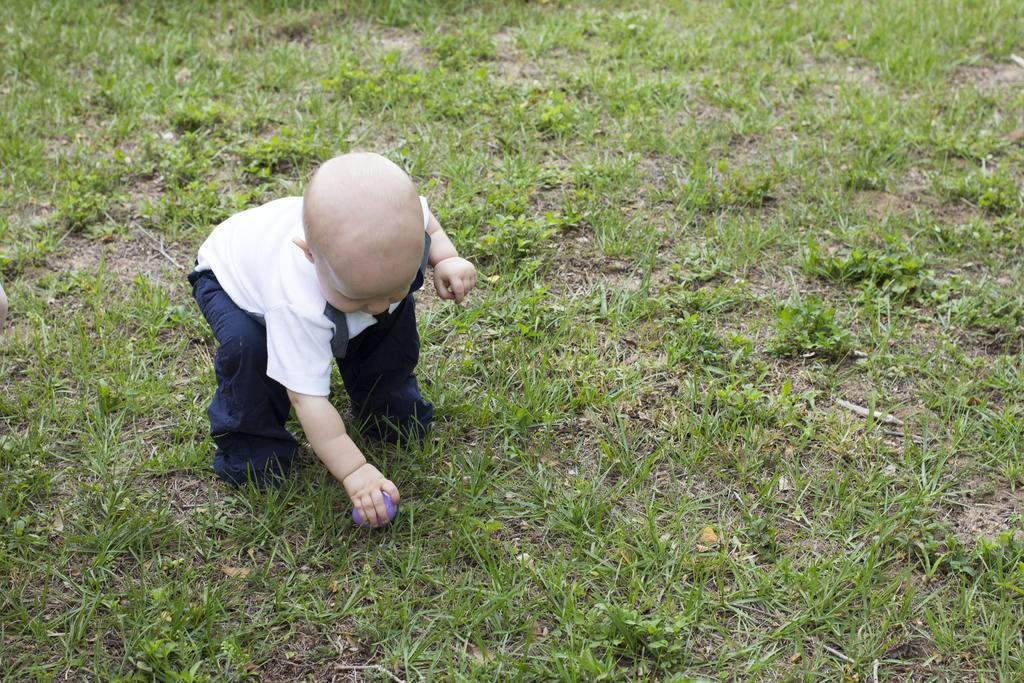Who is the main subject in the image? There is a child in the image. What is the child doing in the image? The child is on the ground and holding a ball. What can be seen in the background of the image? There is grass visible in the background of the image. What verse is the child reciting in the image? There is no indication in the image that the child is reciting a verse. What arithmetic problem is the child solving in the image? There is no arithmetic problem visible in the image. 